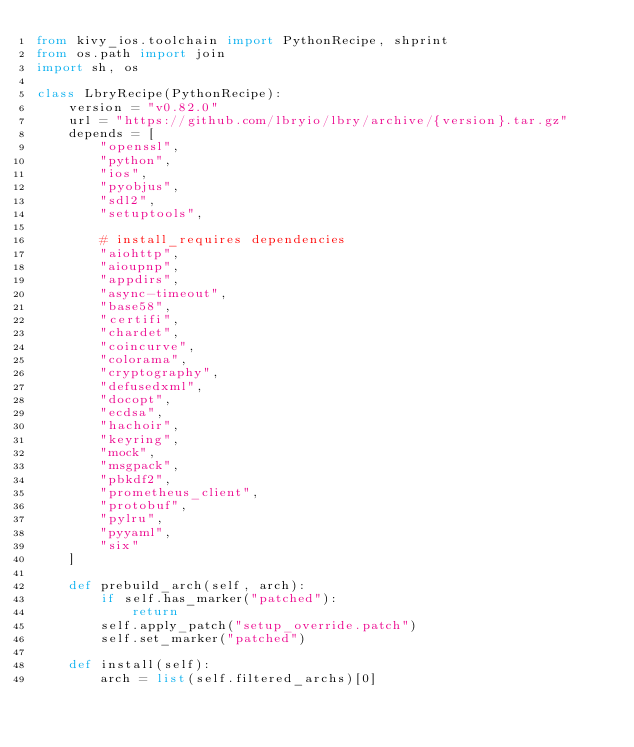<code> <loc_0><loc_0><loc_500><loc_500><_Python_>from kivy_ios.toolchain import PythonRecipe, shprint
from os.path import join
import sh, os

class LbryRecipe(PythonRecipe):
    version = "v0.82.0"
    url = "https://github.com/lbryio/lbry/archive/{version}.tar.gz"
    depends = [
        "openssl",
        "python",
        "ios",
        "pyobjus",
        "sdl2",
        "setuptools",
        
        # install_requires dependencies
        "aiohttp",
        "aioupnp",
        "appdirs",
        "async-timeout",
        "base58",
        "certifi",
        "chardet",
        "coincurve",
        "colorama",
        "cryptography",
        "defusedxml",
        "docopt",
        "ecdsa",
        "hachoir",
        "keyring",
        "mock",
        "msgpack",
        "pbkdf2",
        "prometheus_client",
        "protobuf",
        "pylru",
        "pyyaml",
        "six"
    ]
    
    def prebuild_arch(self, arch):
        if self.has_marker("patched"):
            return
        self.apply_patch("setup_override.patch")
        self.set_marker("patched")
    
    def install(self):
        arch = list(self.filtered_archs)[0]</code> 